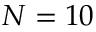<formula> <loc_0><loc_0><loc_500><loc_500>N = 1 0</formula> 